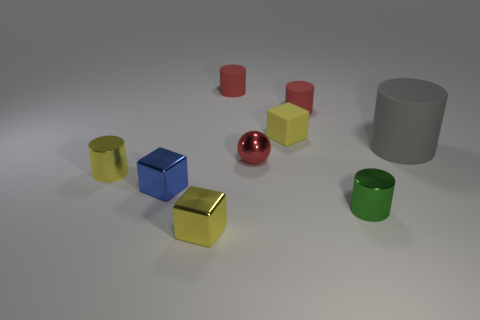Are there any other things that are the same size as the gray matte cylinder?
Give a very brief answer. No. How big is the cube behind the tiny blue shiny object?
Provide a short and direct response. Small. Is there a cyan matte object of the same size as the gray matte cylinder?
Your response must be concise. No. Do the thing that is in front of the green metal thing and the red ball have the same size?
Ensure brevity in your answer.  Yes. How big is the yellow rubber cube?
Provide a short and direct response. Small. What is the color of the cylinder that is in front of the tiny yellow shiny object behind the metal cylinder in front of the small yellow cylinder?
Your response must be concise. Green. There is a tiny rubber object to the left of the red sphere; is it the same color as the tiny shiny sphere?
Ensure brevity in your answer.  Yes. How many small metal objects are both behind the yellow metallic cube and left of the tiny green metallic cylinder?
Provide a short and direct response. 3. There is a yellow shiny thing that is the same shape as the green metallic thing; what size is it?
Give a very brief answer. Small. How many yellow metallic objects are behind the tiny red rubber thing that is to the left of the tiny yellow block behind the big gray rubber object?
Offer a terse response. 0. 